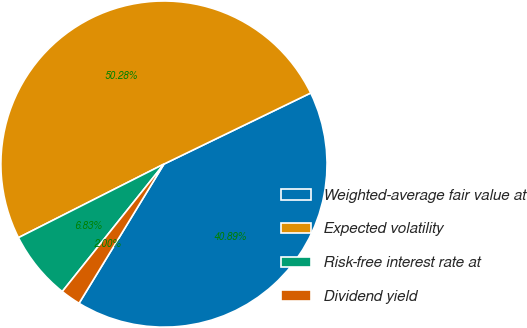Convert chart. <chart><loc_0><loc_0><loc_500><loc_500><pie_chart><fcel>Weighted-average fair value at<fcel>Expected volatility<fcel>Risk-free interest rate at<fcel>Dividend yield<nl><fcel>40.89%<fcel>50.27%<fcel>6.83%<fcel>2.0%<nl></chart> 